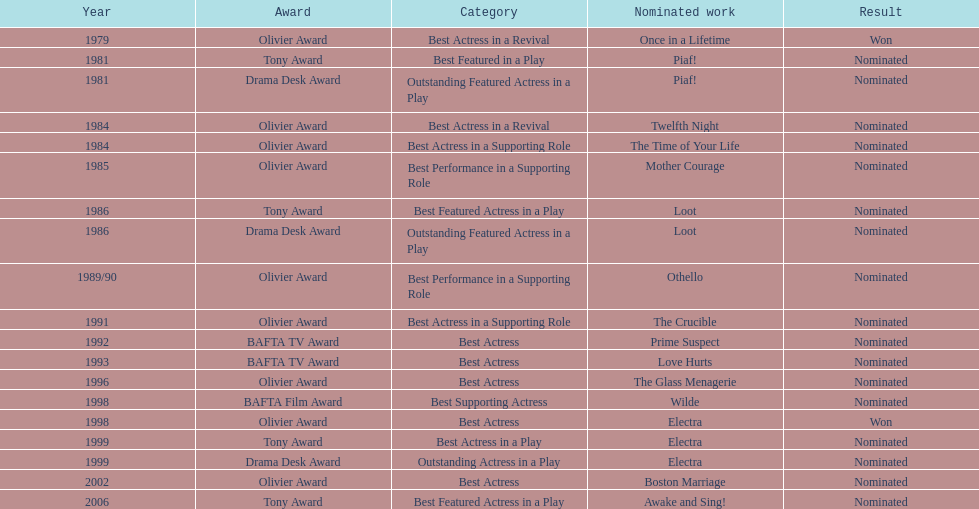What performance earned wanamaker a nomination for best actress in a revival in 1984? Twelfth Night. Can you give me this table as a dict? {'header': ['Year', 'Award', 'Category', 'Nominated work', 'Result'], 'rows': [['1979', 'Olivier Award', 'Best Actress in a Revival', 'Once in a Lifetime', 'Won'], ['1981', 'Tony Award', 'Best Featured in a Play', 'Piaf!', 'Nominated'], ['1981', 'Drama Desk Award', 'Outstanding Featured Actress in a Play', 'Piaf!', 'Nominated'], ['1984', 'Olivier Award', 'Best Actress in a Revival', 'Twelfth Night', 'Nominated'], ['1984', 'Olivier Award', 'Best Actress in a Supporting Role', 'The Time of Your Life', 'Nominated'], ['1985', 'Olivier Award', 'Best Performance in a Supporting Role', 'Mother Courage', 'Nominated'], ['1986', 'Tony Award', 'Best Featured Actress in a Play', 'Loot', 'Nominated'], ['1986', 'Drama Desk Award', 'Outstanding Featured Actress in a Play', 'Loot', 'Nominated'], ['1989/90', 'Olivier Award', 'Best Performance in a Supporting Role', 'Othello', 'Nominated'], ['1991', 'Olivier Award', 'Best Actress in a Supporting Role', 'The Crucible', 'Nominated'], ['1992', 'BAFTA TV Award', 'Best Actress', 'Prime Suspect', 'Nominated'], ['1993', 'BAFTA TV Award', 'Best Actress', 'Love Hurts', 'Nominated'], ['1996', 'Olivier Award', 'Best Actress', 'The Glass Menagerie', 'Nominated'], ['1998', 'BAFTA Film Award', 'Best Supporting Actress', 'Wilde', 'Nominated'], ['1998', 'Olivier Award', 'Best Actress', 'Electra', 'Won'], ['1999', 'Tony Award', 'Best Actress in a Play', 'Electra', 'Nominated'], ['1999', 'Drama Desk Award', 'Outstanding Actress in a Play', 'Electra', 'Nominated'], ['2002', 'Olivier Award', 'Best Actress', 'Boston Marriage', 'Nominated'], ['2006', 'Tony Award', 'Best Featured Actress in a Play', 'Awake and Sing!', 'Nominated']]} 